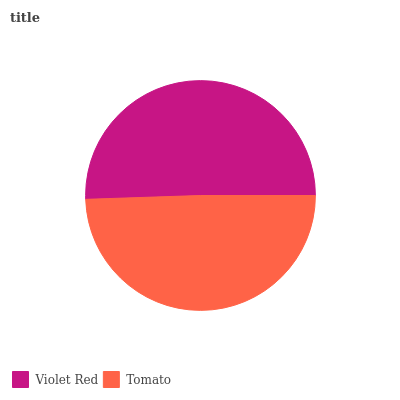Is Tomato the minimum?
Answer yes or no. Yes. Is Violet Red the maximum?
Answer yes or no. Yes. Is Tomato the maximum?
Answer yes or no. No. Is Violet Red greater than Tomato?
Answer yes or no. Yes. Is Tomato less than Violet Red?
Answer yes or no. Yes. Is Tomato greater than Violet Red?
Answer yes or no. No. Is Violet Red less than Tomato?
Answer yes or no. No. Is Violet Red the high median?
Answer yes or no. Yes. Is Tomato the low median?
Answer yes or no. Yes. Is Tomato the high median?
Answer yes or no. No. Is Violet Red the low median?
Answer yes or no. No. 